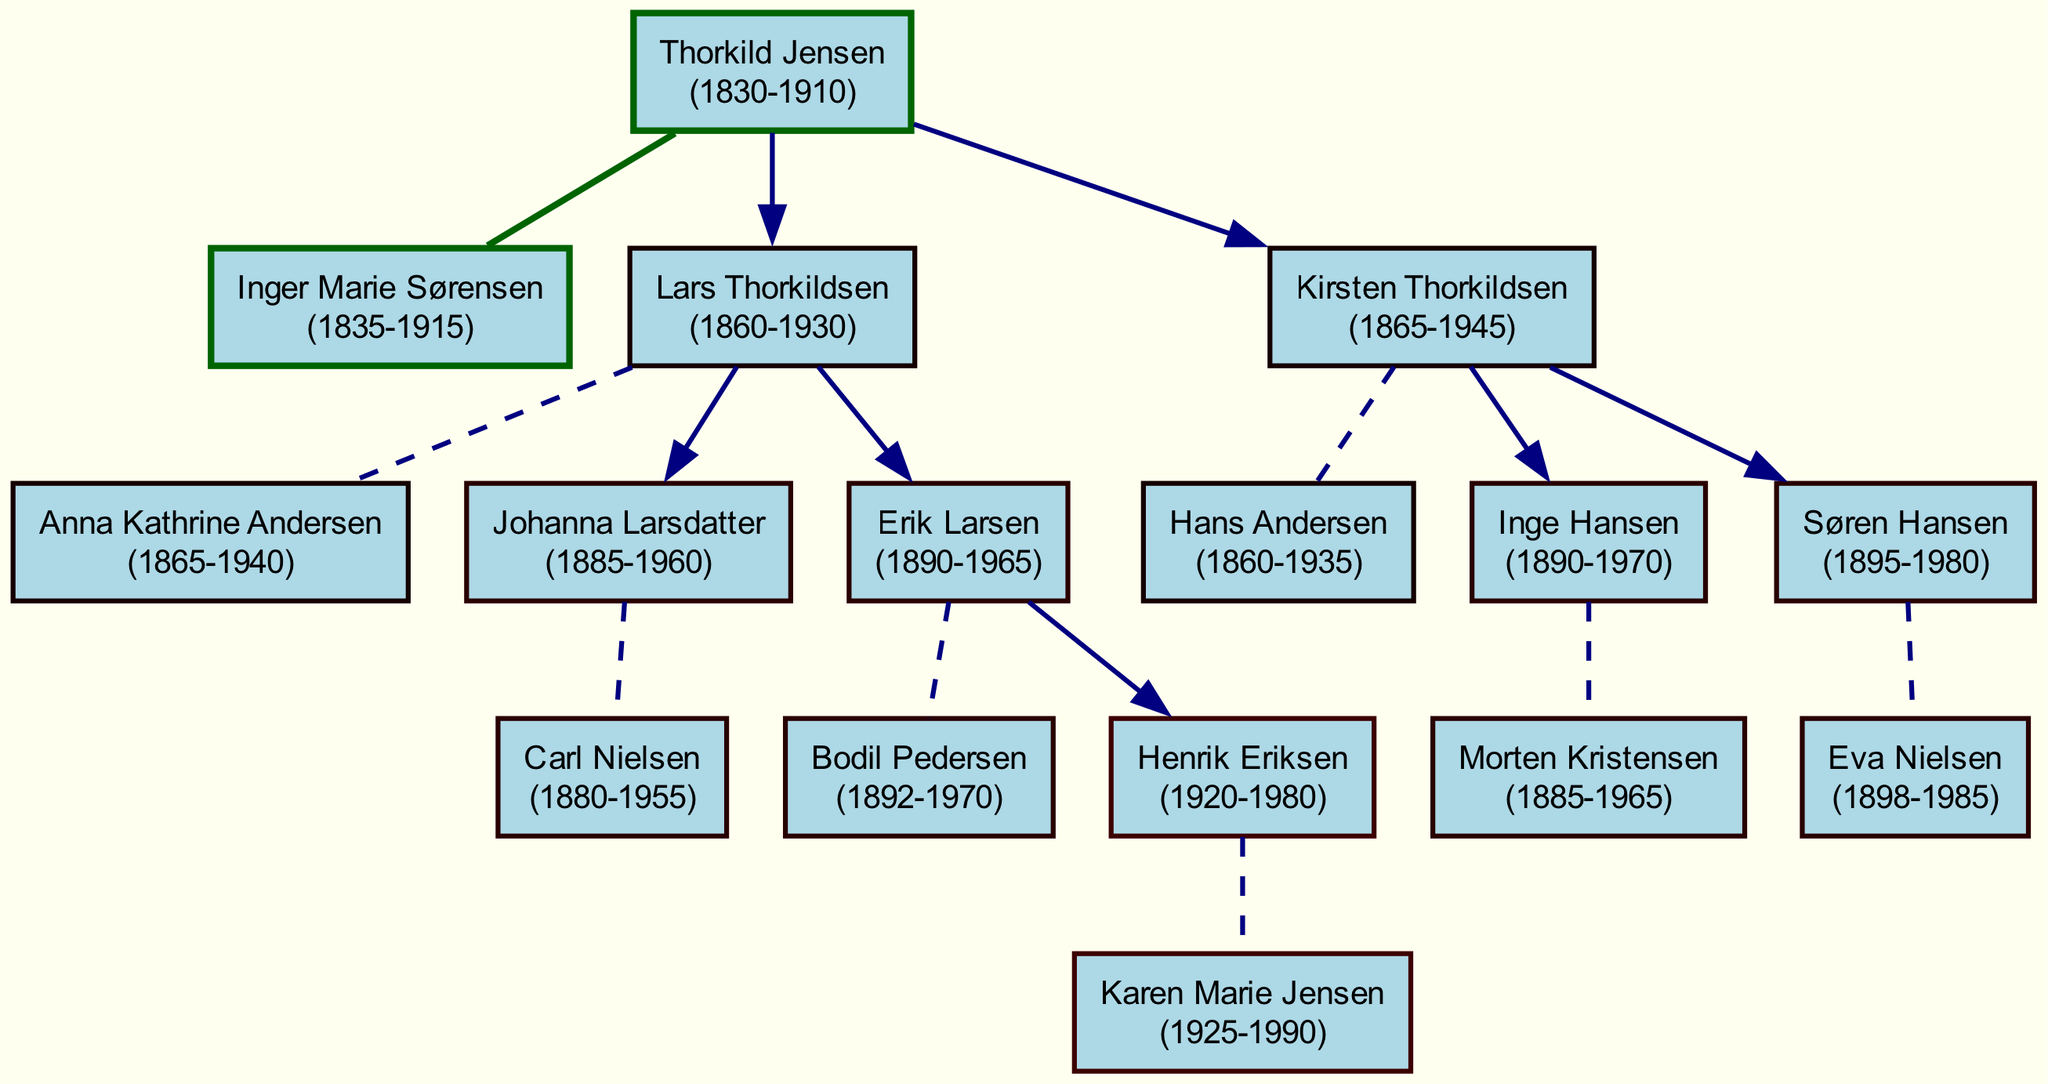What is the birth year of Thorkild Jensen? The birth year of Thorkild Jensen is represented in the diagram based on the information provided in his node, which states "1830".
Answer: 1830 Who is the spouse of Lars Thorkildsen? To answer this question, we can look at the node for Lars Thorkildsen and identify the spouse listed, which is "Anna Kathrine Andersen".
Answer: Anna Kathrine Andersen How many children did Thorkild Jensen have? By counting the nodes connected to Thorkild Jensen's node, we can see there are two direct connections representing children, which are Lars Thorkildsen and Kirsten Thorkildsen.
Answer: 2 Which child of Thorkild Jensen was born in 1895? By examining the nodes that are children of Thorkild Jensen and their respective birth years, we find that Søren Hansen is listed with the birth year "1895".
Answer: Søren Hansen What is the death year of Inge Hansen? To find this, we check the node for Inge Hansen in the diagram, which specifies the death year "1970".
Answer: 1970 Who is the grandchild of Thorkild Jensen that was born in 1920? To answer this correctly, we need to trace the lineage through the children of Thorkild Jensen. Erik Larsen has a child named Henrik Eriksen, who was born in "1920".
Answer: Henrik Eriksen What is the relationship between Johanna Larsdatter and Lars Thorkildsen? By looking at the structure, we see that Johanna Larsdatter is a child of Lars Thorkildsen, making them parent and child.
Answer: Parent and child Which couple in the diagram has the most recent death year? To determine this, we can check the death years of all nodes. The most recent death year is "1990" for Karen Marie Jensen.
Answer: Karen Marie Jensen 